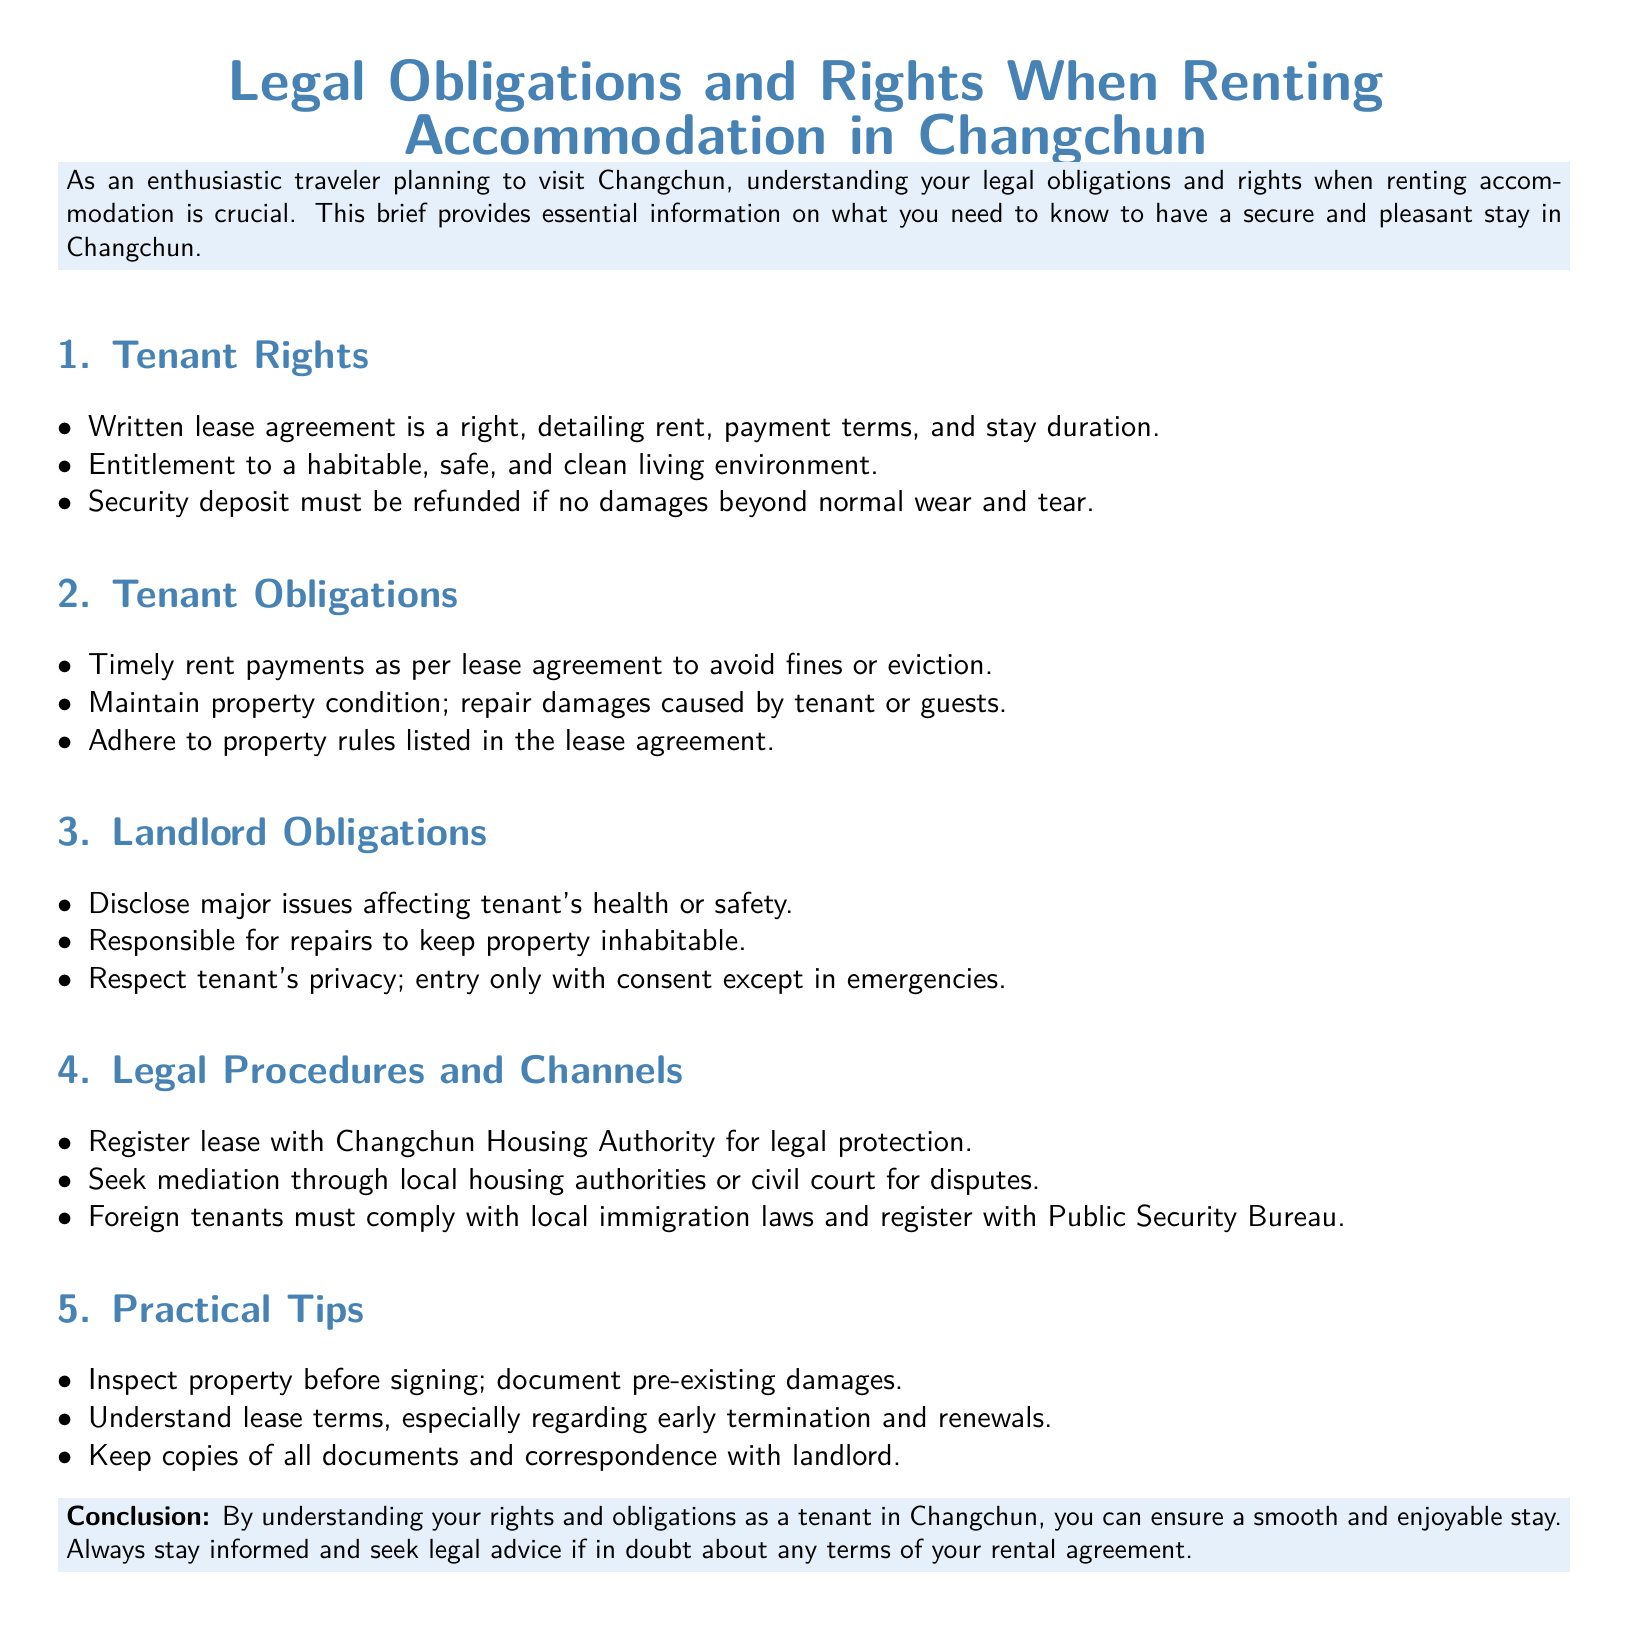What is required in a lease agreement? A lease agreement must be written and detail rent, payment terms, and stay duration.
Answer: Written lease agreement What should be maintained by tenants? Tenants must maintain property condition and repair damages caused by themselves or guests.
Answer: Property condition Who is responsible for repairs? The landlord is responsible for repairs to keep the property inhabitable.
Answer: Landlord When should a lease be registered? It should be registered with the Changchun Housing Authority for legal protection.
Answer: Lease registration What must foreign tenants comply with? Foreign tenants must comply with local immigration laws and register with the Public Security Bureau.
Answer: Local immigration laws What can be done for disputes? Tenants can seek mediation through local housing authorities or civil court for disputes.
Answer: Mediation What must be disclosed by the landlord? The landlord must disclose major issues affecting the tenant's health or safety.
Answer: Major issues What should be documented before signing a lease? Pre-existing damages should be documented before signing the lease.
Answer: Pre-existing damages What must a security deposit be refunded for? A security deposit must be refunded if there are no damages beyond normal wear and tear.
Answer: Normal wear and tear 